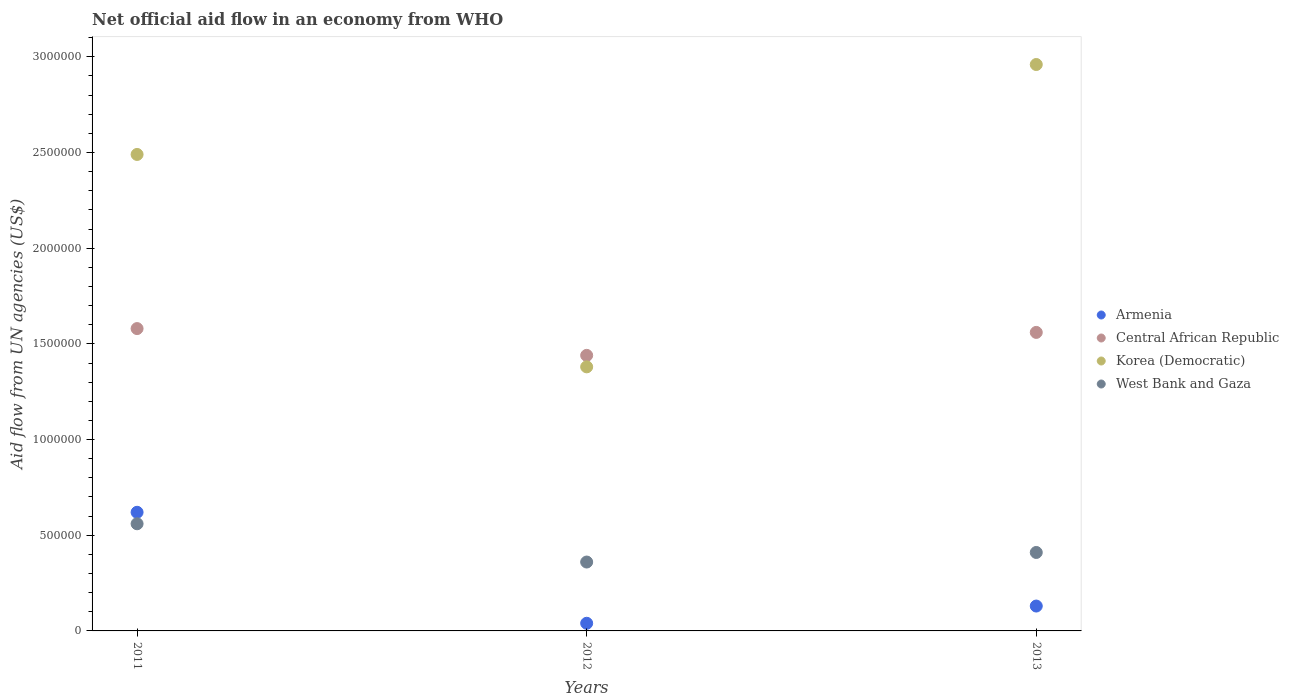How many different coloured dotlines are there?
Your answer should be compact. 4. Is the number of dotlines equal to the number of legend labels?
Your answer should be compact. Yes. What is the net official aid flow in Central African Republic in 2012?
Your response must be concise. 1.44e+06. Across all years, what is the maximum net official aid flow in Central African Republic?
Offer a very short reply. 1.58e+06. Across all years, what is the minimum net official aid flow in Korea (Democratic)?
Your response must be concise. 1.38e+06. In which year was the net official aid flow in Korea (Democratic) maximum?
Provide a succinct answer. 2013. What is the total net official aid flow in Armenia in the graph?
Provide a short and direct response. 7.90e+05. What is the difference between the net official aid flow in Armenia in 2011 and that in 2013?
Ensure brevity in your answer.  4.90e+05. What is the average net official aid flow in Central African Republic per year?
Offer a very short reply. 1.53e+06. In how many years, is the net official aid flow in Armenia greater than 1600000 US$?
Your response must be concise. 0. What is the ratio of the net official aid flow in Central African Republic in 2011 to that in 2012?
Your answer should be compact. 1.1. Is the difference between the net official aid flow in West Bank and Gaza in 2011 and 2013 greater than the difference between the net official aid flow in Armenia in 2011 and 2013?
Offer a terse response. No. What is the difference between the highest and the lowest net official aid flow in West Bank and Gaza?
Offer a terse response. 2.00e+05. Is the sum of the net official aid flow in West Bank and Gaza in 2011 and 2012 greater than the maximum net official aid flow in Central African Republic across all years?
Your response must be concise. No. Is it the case that in every year, the sum of the net official aid flow in Korea (Democratic) and net official aid flow in Central African Republic  is greater than the net official aid flow in West Bank and Gaza?
Give a very brief answer. Yes. Does the net official aid flow in West Bank and Gaza monotonically increase over the years?
Give a very brief answer. No. How many dotlines are there?
Offer a very short reply. 4. How many years are there in the graph?
Offer a terse response. 3. Are the values on the major ticks of Y-axis written in scientific E-notation?
Your answer should be very brief. No. Does the graph contain any zero values?
Keep it short and to the point. No. Does the graph contain grids?
Your response must be concise. No. Where does the legend appear in the graph?
Offer a very short reply. Center right. How many legend labels are there?
Provide a short and direct response. 4. How are the legend labels stacked?
Your answer should be very brief. Vertical. What is the title of the graph?
Ensure brevity in your answer.  Net official aid flow in an economy from WHO. What is the label or title of the X-axis?
Keep it short and to the point. Years. What is the label or title of the Y-axis?
Make the answer very short. Aid flow from UN agencies (US$). What is the Aid flow from UN agencies (US$) in Armenia in 2011?
Provide a succinct answer. 6.20e+05. What is the Aid flow from UN agencies (US$) in Central African Republic in 2011?
Offer a terse response. 1.58e+06. What is the Aid flow from UN agencies (US$) in Korea (Democratic) in 2011?
Offer a very short reply. 2.49e+06. What is the Aid flow from UN agencies (US$) of West Bank and Gaza in 2011?
Your answer should be compact. 5.60e+05. What is the Aid flow from UN agencies (US$) of Central African Republic in 2012?
Make the answer very short. 1.44e+06. What is the Aid flow from UN agencies (US$) in Korea (Democratic) in 2012?
Your answer should be very brief. 1.38e+06. What is the Aid flow from UN agencies (US$) of Armenia in 2013?
Your response must be concise. 1.30e+05. What is the Aid flow from UN agencies (US$) in Central African Republic in 2013?
Keep it short and to the point. 1.56e+06. What is the Aid flow from UN agencies (US$) in Korea (Democratic) in 2013?
Offer a very short reply. 2.96e+06. Across all years, what is the maximum Aid flow from UN agencies (US$) of Armenia?
Give a very brief answer. 6.20e+05. Across all years, what is the maximum Aid flow from UN agencies (US$) in Central African Republic?
Your answer should be very brief. 1.58e+06. Across all years, what is the maximum Aid flow from UN agencies (US$) in Korea (Democratic)?
Offer a terse response. 2.96e+06. Across all years, what is the maximum Aid flow from UN agencies (US$) of West Bank and Gaza?
Keep it short and to the point. 5.60e+05. Across all years, what is the minimum Aid flow from UN agencies (US$) of Central African Republic?
Your response must be concise. 1.44e+06. Across all years, what is the minimum Aid flow from UN agencies (US$) in Korea (Democratic)?
Offer a very short reply. 1.38e+06. What is the total Aid flow from UN agencies (US$) of Armenia in the graph?
Ensure brevity in your answer.  7.90e+05. What is the total Aid flow from UN agencies (US$) of Central African Republic in the graph?
Your answer should be very brief. 4.58e+06. What is the total Aid flow from UN agencies (US$) in Korea (Democratic) in the graph?
Ensure brevity in your answer.  6.83e+06. What is the total Aid flow from UN agencies (US$) in West Bank and Gaza in the graph?
Your response must be concise. 1.33e+06. What is the difference between the Aid flow from UN agencies (US$) of Armenia in 2011 and that in 2012?
Give a very brief answer. 5.80e+05. What is the difference between the Aid flow from UN agencies (US$) in Korea (Democratic) in 2011 and that in 2012?
Your answer should be very brief. 1.11e+06. What is the difference between the Aid flow from UN agencies (US$) in Armenia in 2011 and that in 2013?
Your answer should be very brief. 4.90e+05. What is the difference between the Aid flow from UN agencies (US$) of Central African Republic in 2011 and that in 2013?
Your answer should be very brief. 2.00e+04. What is the difference between the Aid flow from UN agencies (US$) of Korea (Democratic) in 2011 and that in 2013?
Offer a very short reply. -4.70e+05. What is the difference between the Aid flow from UN agencies (US$) of West Bank and Gaza in 2011 and that in 2013?
Your answer should be compact. 1.50e+05. What is the difference between the Aid flow from UN agencies (US$) of Armenia in 2012 and that in 2013?
Your response must be concise. -9.00e+04. What is the difference between the Aid flow from UN agencies (US$) of Central African Republic in 2012 and that in 2013?
Offer a very short reply. -1.20e+05. What is the difference between the Aid flow from UN agencies (US$) in Korea (Democratic) in 2012 and that in 2013?
Your response must be concise. -1.58e+06. What is the difference between the Aid flow from UN agencies (US$) in Armenia in 2011 and the Aid flow from UN agencies (US$) in Central African Republic in 2012?
Offer a terse response. -8.20e+05. What is the difference between the Aid flow from UN agencies (US$) of Armenia in 2011 and the Aid flow from UN agencies (US$) of Korea (Democratic) in 2012?
Keep it short and to the point. -7.60e+05. What is the difference between the Aid flow from UN agencies (US$) of Armenia in 2011 and the Aid flow from UN agencies (US$) of West Bank and Gaza in 2012?
Your answer should be very brief. 2.60e+05. What is the difference between the Aid flow from UN agencies (US$) in Central African Republic in 2011 and the Aid flow from UN agencies (US$) in West Bank and Gaza in 2012?
Provide a succinct answer. 1.22e+06. What is the difference between the Aid flow from UN agencies (US$) of Korea (Democratic) in 2011 and the Aid flow from UN agencies (US$) of West Bank and Gaza in 2012?
Offer a terse response. 2.13e+06. What is the difference between the Aid flow from UN agencies (US$) in Armenia in 2011 and the Aid flow from UN agencies (US$) in Central African Republic in 2013?
Keep it short and to the point. -9.40e+05. What is the difference between the Aid flow from UN agencies (US$) in Armenia in 2011 and the Aid flow from UN agencies (US$) in Korea (Democratic) in 2013?
Ensure brevity in your answer.  -2.34e+06. What is the difference between the Aid flow from UN agencies (US$) in Central African Republic in 2011 and the Aid flow from UN agencies (US$) in Korea (Democratic) in 2013?
Provide a short and direct response. -1.38e+06. What is the difference between the Aid flow from UN agencies (US$) in Central African Republic in 2011 and the Aid flow from UN agencies (US$) in West Bank and Gaza in 2013?
Your answer should be very brief. 1.17e+06. What is the difference between the Aid flow from UN agencies (US$) in Korea (Democratic) in 2011 and the Aid flow from UN agencies (US$) in West Bank and Gaza in 2013?
Offer a very short reply. 2.08e+06. What is the difference between the Aid flow from UN agencies (US$) of Armenia in 2012 and the Aid flow from UN agencies (US$) of Central African Republic in 2013?
Provide a succinct answer. -1.52e+06. What is the difference between the Aid flow from UN agencies (US$) of Armenia in 2012 and the Aid flow from UN agencies (US$) of Korea (Democratic) in 2013?
Your response must be concise. -2.92e+06. What is the difference between the Aid flow from UN agencies (US$) in Armenia in 2012 and the Aid flow from UN agencies (US$) in West Bank and Gaza in 2013?
Ensure brevity in your answer.  -3.70e+05. What is the difference between the Aid flow from UN agencies (US$) in Central African Republic in 2012 and the Aid flow from UN agencies (US$) in Korea (Democratic) in 2013?
Offer a terse response. -1.52e+06. What is the difference between the Aid flow from UN agencies (US$) in Central African Republic in 2012 and the Aid flow from UN agencies (US$) in West Bank and Gaza in 2013?
Offer a very short reply. 1.03e+06. What is the difference between the Aid flow from UN agencies (US$) in Korea (Democratic) in 2012 and the Aid flow from UN agencies (US$) in West Bank and Gaza in 2013?
Make the answer very short. 9.70e+05. What is the average Aid flow from UN agencies (US$) in Armenia per year?
Your response must be concise. 2.63e+05. What is the average Aid flow from UN agencies (US$) of Central African Republic per year?
Offer a terse response. 1.53e+06. What is the average Aid flow from UN agencies (US$) of Korea (Democratic) per year?
Your response must be concise. 2.28e+06. What is the average Aid flow from UN agencies (US$) in West Bank and Gaza per year?
Keep it short and to the point. 4.43e+05. In the year 2011, what is the difference between the Aid flow from UN agencies (US$) of Armenia and Aid flow from UN agencies (US$) of Central African Republic?
Provide a short and direct response. -9.60e+05. In the year 2011, what is the difference between the Aid flow from UN agencies (US$) of Armenia and Aid flow from UN agencies (US$) of Korea (Democratic)?
Make the answer very short. -1.87e+06. In the year 2011, what is the difference between the Aid flow from UN agencies (US$) of Armenia and Aid flow from UN agencies (US$) of West Bank and Gaza?
Make the answer very short. 6.00e+04. In the year 2011, what is the difference between the Aid flow from UN agencies (US$) in Central African Republic and Aid flow from UN agencies (US$) in Korea (Democratic)?
Give a very brief answer. -9.10e+05. In the year 2011, what is the difference between the Aid flow from UN agencies (US$) in Central African Republic and Aid flow from UN agencies (US$) in West Bank and Gaza?
Provide a succinct answer. 1.02e+06. In the year 2011, what is the difference between the Aid flow from UN agencies (US$) in Korea (Democratic) and Aid flow from UN agencies (US$) in West Bank and Gaza?
Offer a very short reply. 1.93e+06. In the year 2012, what is the difference between the Aid flow from UN agencies (US$) of Armenia and Aid flow from UN agencies (US$) of Central African Republic?
Give a very brief answer. -1.40e+06. In the year 2012, what is the difference between the Aid flow from UN agencies (US$) in Armenia and Aid flow from UN agencies (US$) in Korea (Democratic)?
Provide a short and direct response. -1.34e+06. In the year 2012, what is the difference between the Aid flow from UN agencies (US$) in Armenia and Aid flow from UN agencies (US$) in West Bank and Gaza?
Keep it short and to the point. -3.20e+05. In the year 2012, what is the difference between the Aid flow from UN agencies (US$) of Central African Republic and Aid flow from UN agencies (US$) of West Bank and Gaza?
Your response must be concise. 1.08e+06. In the year 2012, what is the difference between the Aid flow from UN agencies (US$) in Korea (Democratic) and Aid flow from UN agencies (US$) in West Bank and Gaza?
Your response must be concise. 1.02e+06. In the year 2013, what is the difference between the Aid flow from UN agencies (US$) in Armenia and Aid flow from UN agencies (US$) in Central African Republic?
Offer a terse response. -1.43e+06. In the year 2013, what is the difference between the Aid flow from UN agencies (US$) in Armenia and Aid flow from UN agencies (US$) in Korea (Democratic)?
Give a very brief answer. -2.83e+06. In the year 2013, what is the difference between the Aid flow from UN agencies (US$) of Armenia and Aid flow from UN agencies (US$) of West Bank and Gaza?
Provide a short and direct response. -2.80e+05. In the year 2013, what is the difference between the Aid flow from UN agencies (US$) of Central African Republic and Aid flow from UN agencies (US$) of Korea (Democratic)?
Your answer should be very brief. -1.40e+06. In the year 2013, what is the difference between the Aid flow from UN agencies (US$) in Central African Republic and Aid flow from UN agencies (US$) in West Bank and Gaza?
Ensure brevity in your answer.  1.15e+06. In the year 2013, what is the difference between the Aid flow from UN agencies (US$) in Korea (Democratic) and Aid flow from UN agencies (US$) in West Bank and Gaza?
Keep it short and to the point. 2.55e+06. What is the ratio of the Aid flow from UN agencies (US$) in Central African Republic in 2011 to that in 2012?
Your answer should be very brief. 1.1. What is the ratio of the Aid flow from UN agencies (US$) of Korea (Democratic) in 2011 to that in 2012?
Your answer should be very brief. 1.8. What is the ratio of the Aid flow from UN agencies (US$) in West Bank and Gaza in 2011 to that in 2012?
Give a very brief answer. 1.56. What is the ratio of the Aid flow from UN agencies (US$) in Armenia in 2011 to that in 2013?
Provide a succinct answer. 4.77. What is the ratio of the Aid flow from UN agencies (US$) of Central African Republic in 2011 to that in 2013?
Your answer should be compact. 1.01. What is the ratio of the Aid flow from UN agencies (US$) in Korea (Democratic) in 2011 to that in 2013?
Make the answer very short. 0.84. What is the ratio of the Aid flow from UN agencies (US$) of West Bank and Gaza in 2011 to that in 2013?
Give a very brief answer. 1.37. What is the ratio of the Aid flow from UN agencies (US$) in Armenia in 2012 to that in 2013?
Give a very brief answer. 0.31. What is the ratio of the Aid flow from UN agencies (US$) of Central African Republic in 2012 to that in 2013?
Keep it short and to the point. 0.92. What is the ratio of the Aid flow from UN agencies (US$) of Korea (Democratic) in 2012 to that in 2013?
Your answer should be very brief. 0.47. What is the ratio of the Aid flow from UN agencies (US$) of West Bank and Gaza in 2012 to that in 2013?
Your answer should be very brief. 0.88. What is the difference between the highest and the second highest Aid flow from UN agencies (US$) of Armenia?
Your answer should be very brief. 4.90e+05. What is the difference between the highest and the second highest Aid flow from UN agencies (US$) of West Bank and Gaza?
Keep it short and to the point. 1.50e+05. What is the difference between the highest and the lowest Aid flow from UN agencies (US$) in Armenia?
Your response must be concise. 5.80e+05. What is the difference between the highest and the lowest Aid flow from UN agencies (US$) in Central African Republic?
Your response must be concise. 1.40e+05. What is the difference between the highest and the lowest Aid flow from UN agencies (US$) of Korea (Democratic)?
Your answer should be very brief. 1.58e+06. 